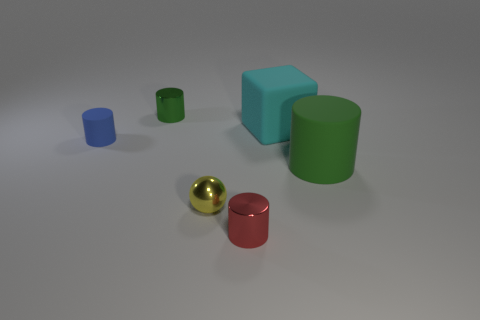How many green cylinders must be subtracted to get 1 green cylinders? 1 Subtract all spheres. How many objects are left? 5 Subtract 1 spheres. How many spheres are left? 0 Add 3 cyan balls. How many objects exist? 9 Subtract all big cylinders. How many cylinders are left? 3 Subtract all green spheres. How many blue cylinders are left? 1 Subtract all blue cylinders. How many cylinders are left? 3 Subtract 0 gray cylinders. How many objects are left? 6 Subtract all cyan cylinders. Subtract all red spheres. How many cylinders are left? 4 Subtract all shiny cylinders. Subtract all green matte cylinders. How many objects are left? 3 